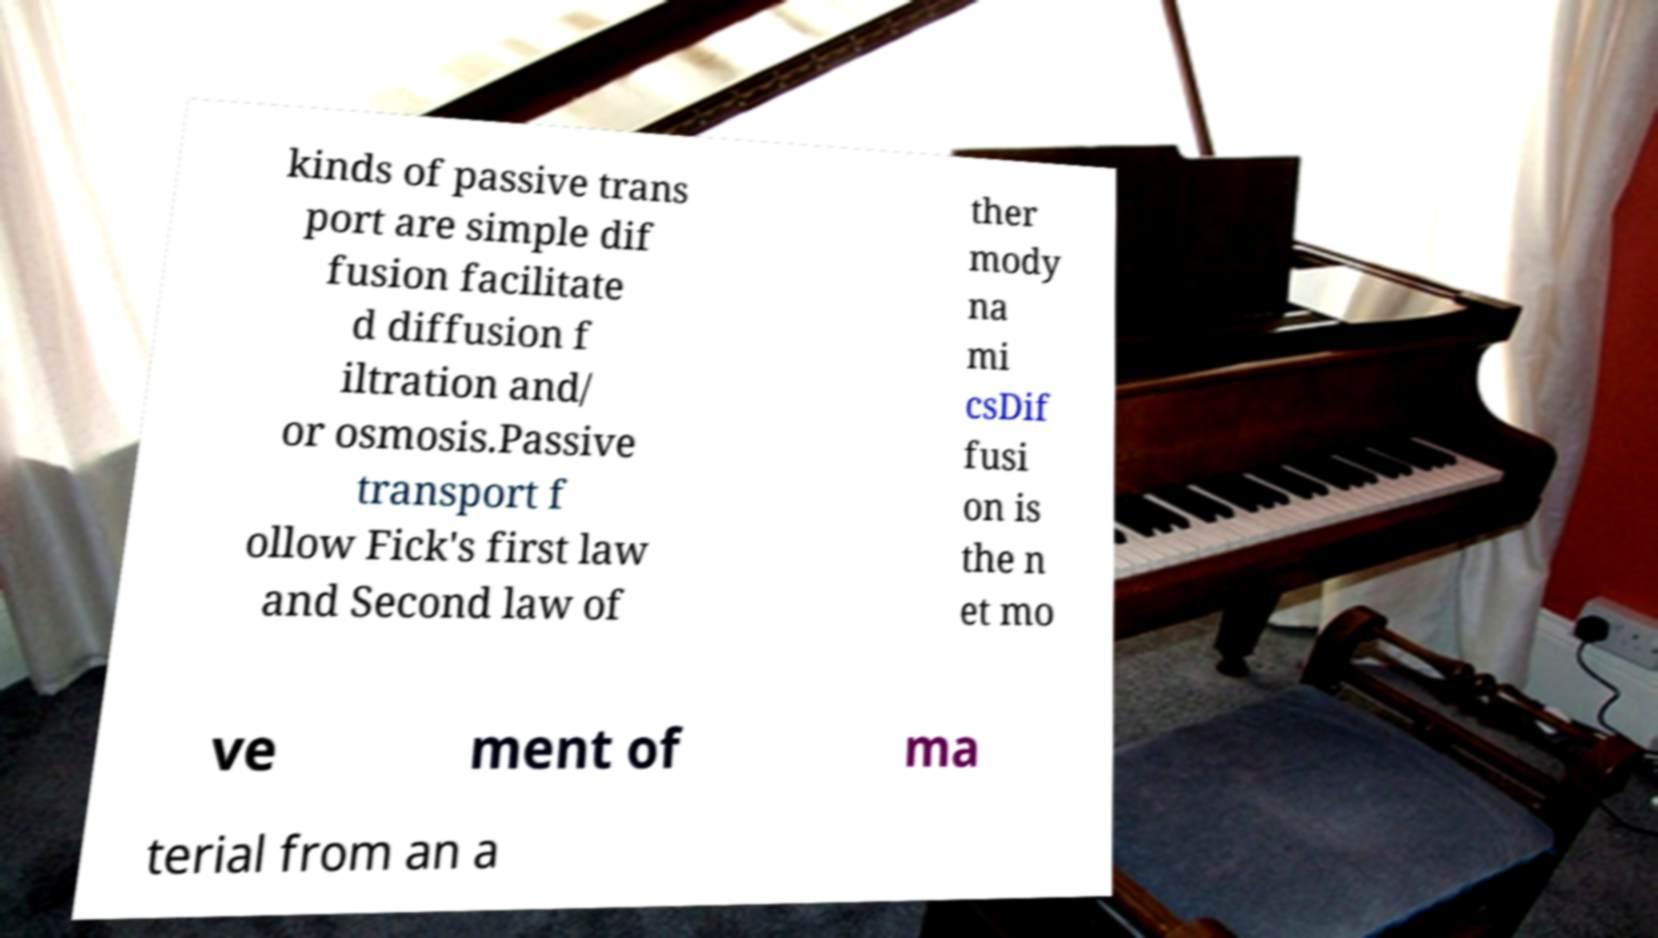Please read and relay the text visible in this image. What does it say? kinds of passive trans port are simple dif fusion facilitate d diffusion f iltration and/ or osmosis.Passive transport f ollow Fick's first law and Second law of ther mody na mi csDif fusi on is the n et mo ve ment of ma terial from an a 